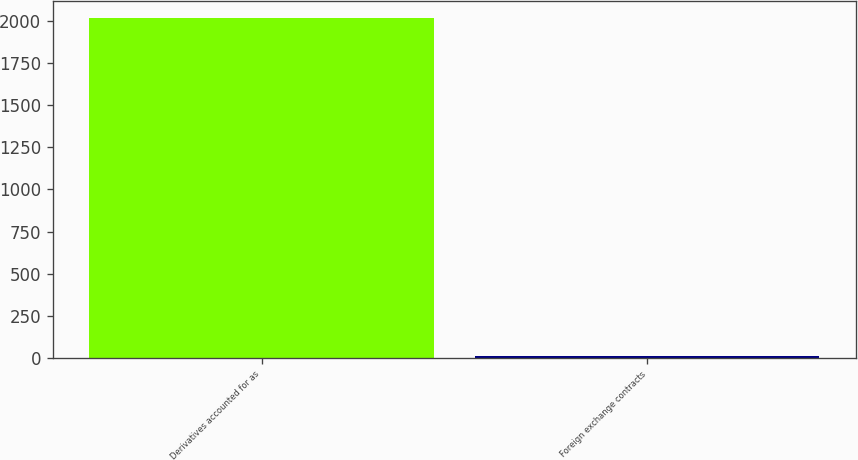Convert chart. <chart><loc_0><loc_0><loc_500><loc_500><bar_chart><fcel>Derivatives accounted for as<fcel>Foreign exchange contracts<nl><fcel>2015<fcel>13<nl></chart> 